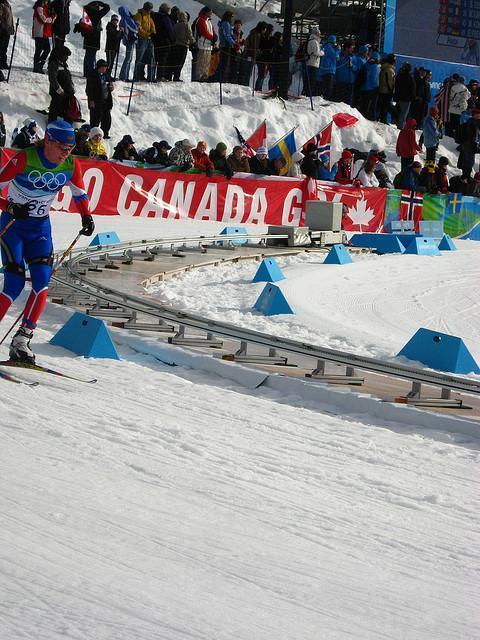How many white circles are on the skiers shirt?
Give a very brief answer. 5. How many people can you see?
Give a very brief answer. 2. 